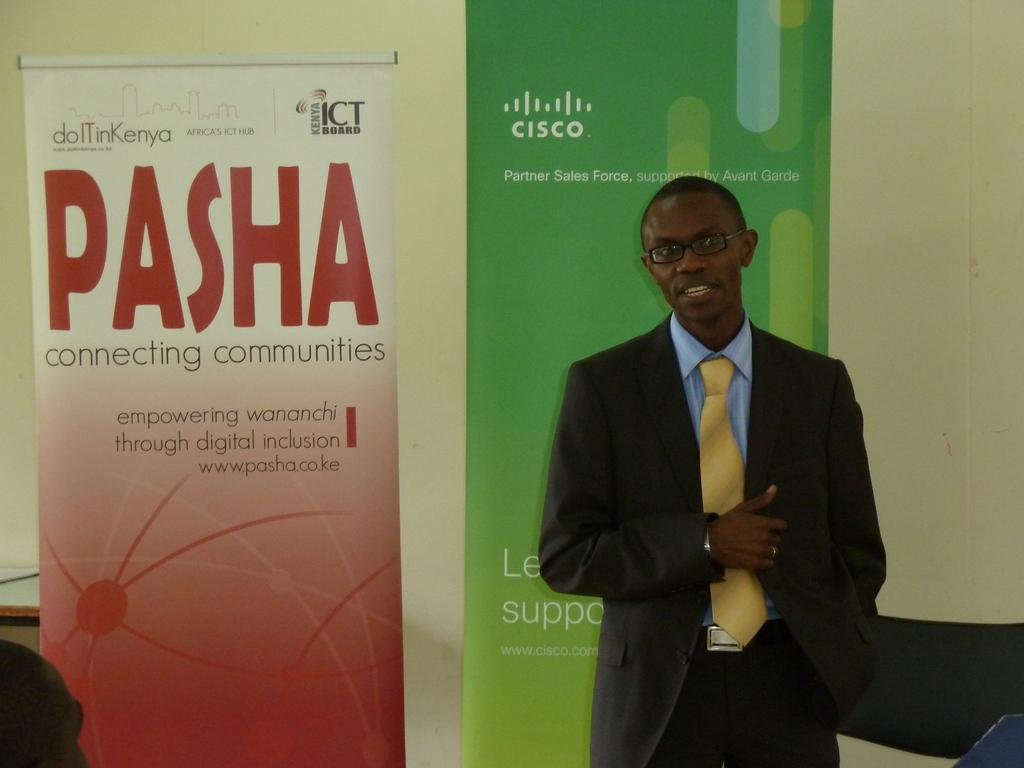<image>
Create a compact narrative representing the image presented. A man in a suit is standing under a Cisco sign. 